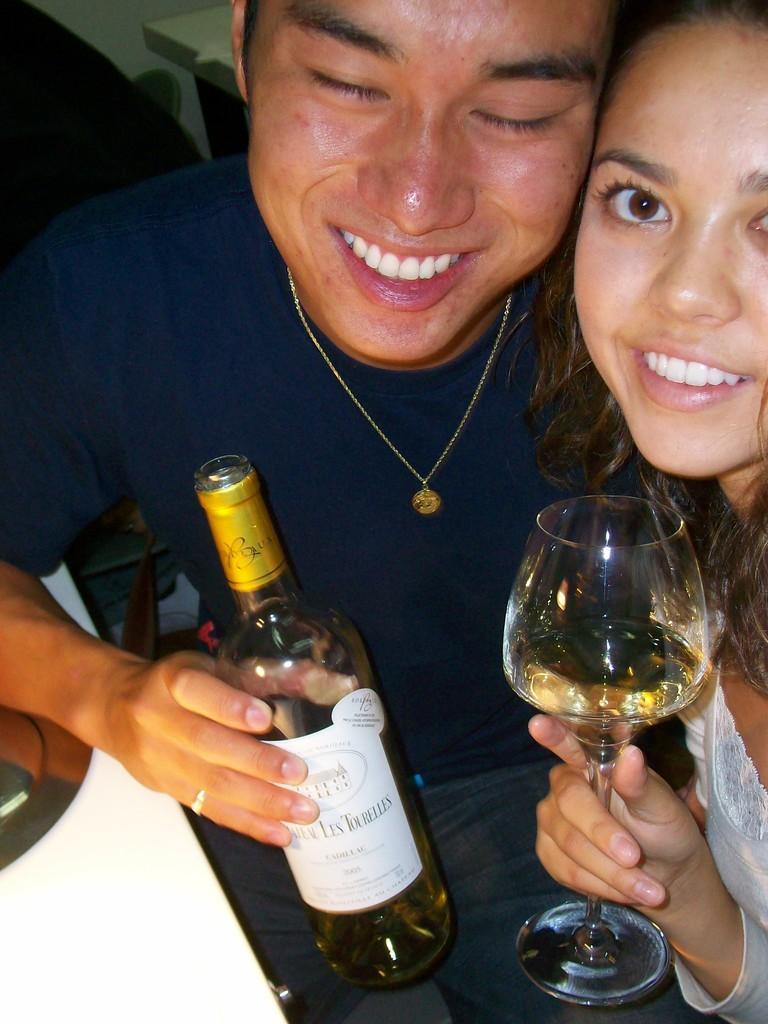In one or two sentences, can you explain what this image depicts? This picture describe about two members in the photograph, On the left we can see a boy wearing blue t- shirt is smiling and holding the wine bottle in the left hand and on the right a girl wearing white dress is holding the wine glass in her and and smiling and seeing towards the camera. 